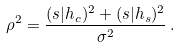Convert formula to latex. <formula><loc_0><loc_0><loc_500><loc_500>\rho ^ { 2 } = \frac { ( s | h _ { c } ) ^ { 2 } + ( s | h _ { s } ) ^ { 2 } } { \sigma ^ { 2 } } \, .</formula> 